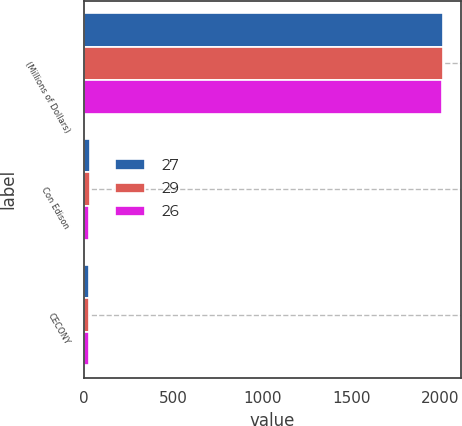<chart> <loc_0><loc_0><loc_500><loc_500><stacked_bar_chart><ecel><fcel>(Millions of Dollars)<fcel>Con Edison<fcel>CECONY<nl><fcel>27<fcel>2015<fcel>34<fcel>29<nl><fcel>29<fcel>2014<fcel>32<fcel>27<nl><fcel>26<fcel>2013<fcel>30<fcel>26<nl></chart> 